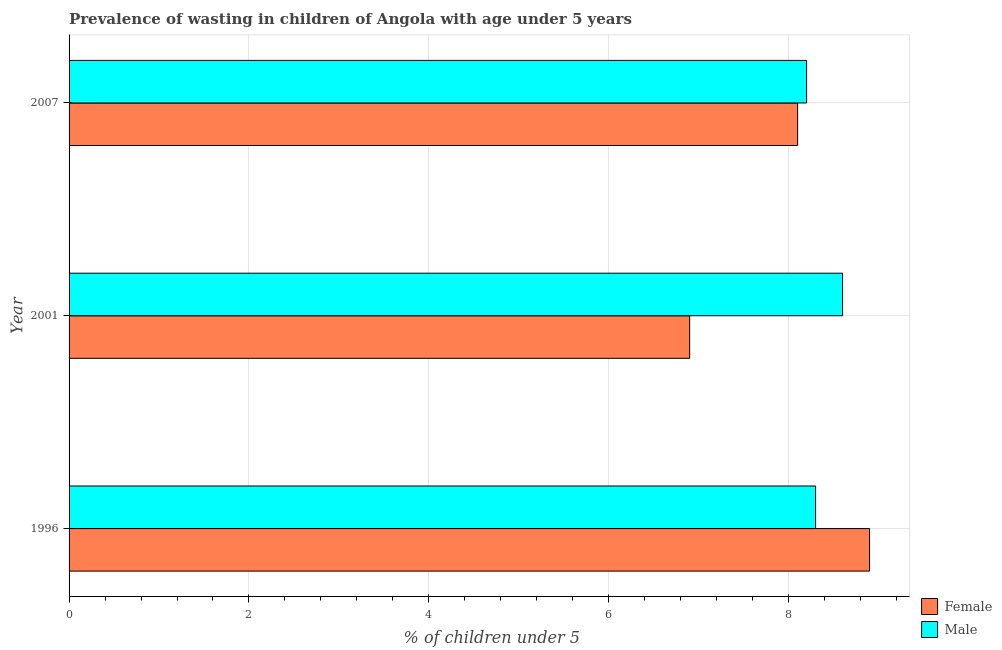Are the number of bars per tick equal to the number of legend labels?
Provide a short and direct response. Yes. How many bars are there on the 1st tick from the top?
Make the answer very short. 2. What is the label of the 1st group of bars from the top?
Your answer should be compact. 2007. In how many cases, is the number of bars for a given year not equal to the number of legend labels?
Keep it short and to the point. 0. What is the percentage of undernourished male children in 1996?
Keep it short and to the point. 8.3. Across all years, what is the maximum percentage of undernourished female children?
Ensure brevity in your answer.  8.9. Across all years, what is the minimum percentage of undernourished male children?
Your response must be concise. 8.2. In which year was the percentage of undernourished female children maximum?
Give a very brief answer. 1996. What is the total percentage of undernourished female children in the graph?
Make the answer very short. 23.9. What is the difference between the percentage of undernourished female children in 1996 and the percentage of undernourished male children in 2007?
Your response must be concise. 0.7. What is the average percentage of undernourished male children per year?
Your answer should be very brief. 8.37. In the year 2001, what is the difference between the percentage of undernourished female children and percentage of undernourished male children?
Provide a short and direct response. -1.7. In how many years, is the percentage of undernourished female children greater than 6.8 %?
Your response must be concise. 3. What is the ratio of the percentage of undernourished female children in 2001 to that in 2007?
Give a very brief answer. 0.85. Is the percentage of undernourished female children in 2001 less than that in 2007?
Make the answer very short. Yes. Is the difference between the percentage of undernourished male children in 1996 and 2001 greater than the difference between the percentage of undernourished female children in 1996 and 2001?
Make the answer very short. No. What is the difference between the highest and the lowest percentage of undernourished male children?
Your answer should be compact. 0.4. In how many years, is the percentage of undernourished female children greater than the average percentage of undernourished female children taken over all years?
Provide a succinct answer. 2. Is the sum of the percentage of undernourished female children in 2001 and 2007 greater than the maximum percentage of undernourished male children across all years?
Give a very brief answer. Yes. What does the 2nd bar from the bottom in 2001 represents?
Ensure brevity in your answer.  Male. How many bars are there?
Ensure brevity in your answer.  6. How many years are there in the graph?
Offer a very short reply. 3. Does the graph contain any zero values?
Your answer should be very brief. No. Does the graph contain grids?
Make the answer very short. Yes. Where does the legend appear in the graph?
Your response must be concise. Bottom right. What is the title of the graph?
Offer a very short reply. Prevalence of wasting in children of Angola with age under 5 years. What is the label or title of the X-axis?
Your answer should be very brief.  % of children under 5. What is the label or title of the Y-axis?
Ensure brevity in your answer.  Year. What is the  % of children under 5 in Female in 1996?
Your response must be concise. 8.9. What is the  % of children under 5 in Male in 1996?
Offer a very short reply. 8.3. What is the  % of children under 5 in Female in 2001?
Offer a terse response. 6.9. What is the  % of children under 5 of Male in 2001?
Offer a very short reply. 8.6. What is the  % of children under 5 in Female in 2007?
Give a very brief answer. 8.1. What is the  % of children under 5 of Male in 2007?
Keep it short and to the point. 8.2. Across all years, what is the maximum  % of children under 5 in Female?
Provide a short and direct response. 8.9. Across all years, what is the maximum  % of children under 5 of Male?
Make the answer very short. 8.6. Across all years, what is the minimum  % of children under 5 in Female?
Ensure brevity in your answer.  6.9. Across all years, what is the minimum  % of children under 5 of Male?
Your response must be concise. 8.2. What is the total  % of children under 5 of Female in the graph?
Give a very brief answer. 23.9. What is the total  % of children under 5 in Male in the graph?
Offer a terse response. 25.1. What is the difference between the  % of children under 5 of Female in 1996 and that in 2001?
Your answer should be compact. 2. What is the difference between the  % of children under 5 of Male in 1996 and that in 2001?
Your response must be concise. -0.3. What is the difference between the  % of children under 5 in Female in 1996 and that in 2007?
Provide a short and direct response. 0.8. What is the difference between the  % of children under 5 of Male in 2001 and that in 2007?
Provide a succinct answer. 0.4. What is the difference between the  % of children under 5 in Female in 1996 and the  % of children under 5 in Male in 2001?
Your response must be concise. 0.3. What is the average  % of children under 5 in Female per year?
Keep it short and to the point. 7.97. What is the average  % of children under 5 in Male per year?
Your answer should be very brief. 8.37. In the year 1996, what is the difference between the  % of children under 5 of Female and  % of children under 5 of Male?
Provide a succinct answer. 0.6. In the year 2001, what is the difference between the  % of children under 5 of Female and  % of children under 5 of Male?
Offer a very short reply. -1.7. What is the ratio of the  % of children under 5 of Female in 1996 to that in 2001?
Offer a very short reply. 1.29. What is the ratio of the  % of children under 5 of Male in 1996 to that in 2001?
Your answer should be very brief. 0.97. What is the ratio of the  % of children under 5 of Female in 1996 to that in 2007?
Your answer should be very brief. 1.1. What is the ratio of the  % of children under 5 in Male in 1996 to that in 2007?
Offer a very short reply. 1.01. What is the ratio of the  % of children under 5 in Female in 2001 to that in 2007?
Your response must be concise. 0.85. What is the ratio of the  % of children under 5 of Male in 2001 to that in 2007?
Provide a succinct answer. 1.05. What is the difference between the highest and the second highest  % of children under 5 of Male?
Ensure brevity in your answer.  0.3. What is the difference between the highest and the lowest  % of children under 5 in Female?
Your response must be concise. 2. 